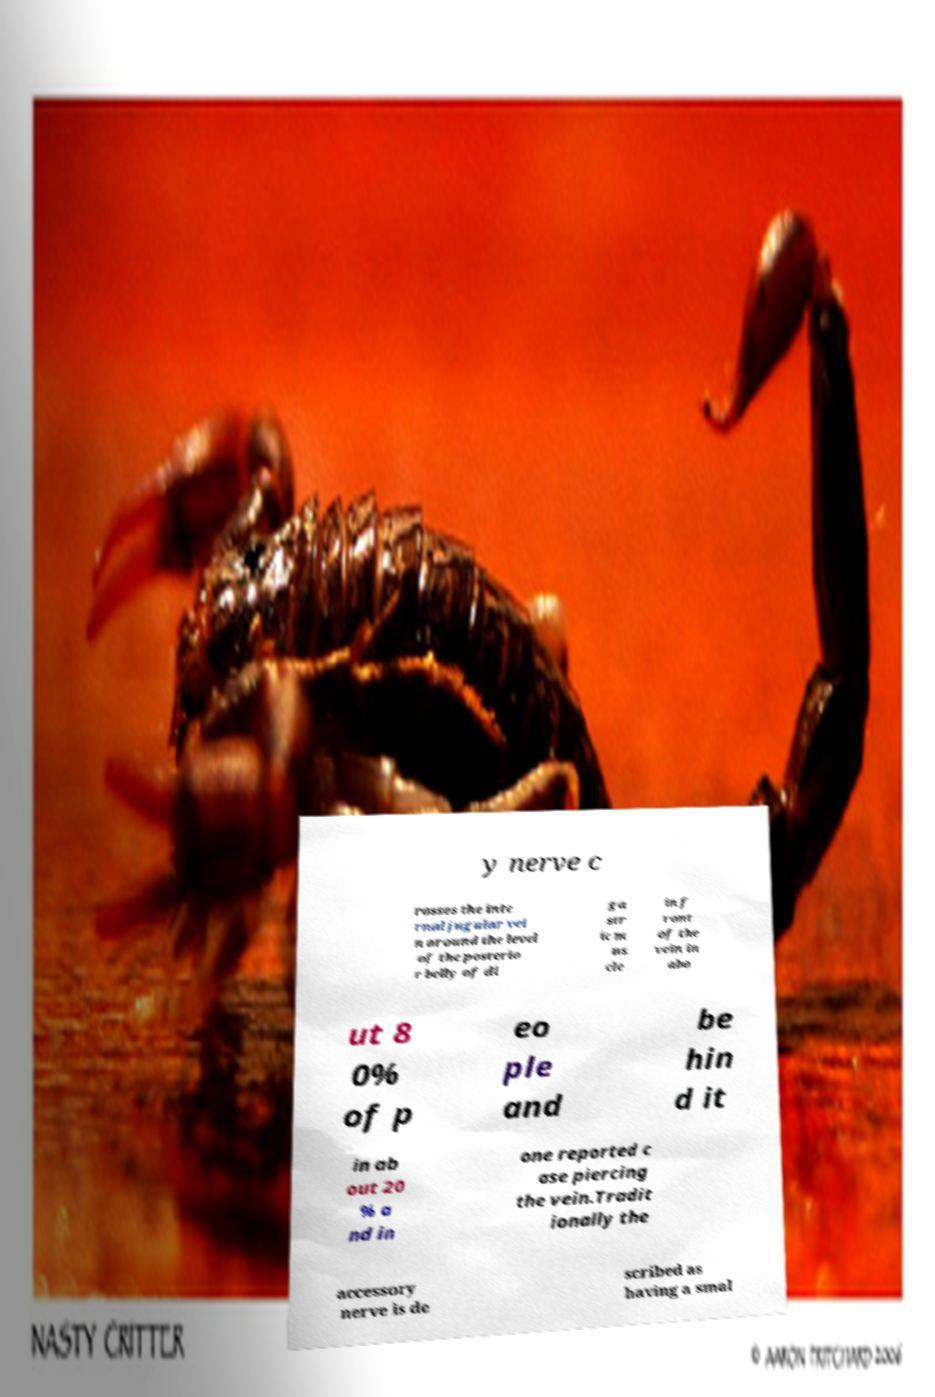Can you read and provide the text displayed in the image?This photo seems to have some interesting text. Can you extract and type it out for me? y nerve c rosses the inte rnal jugular vei n around the level of the posterio r belly of di ga str ic m us cle in f ront of the vein in abo ut 8 0% of p eo ple and be hin d it in ab out 20 % a nd in one reported c ase piercing the vein.Tradit ionally the accessory nerve is de scribed as having a smal 